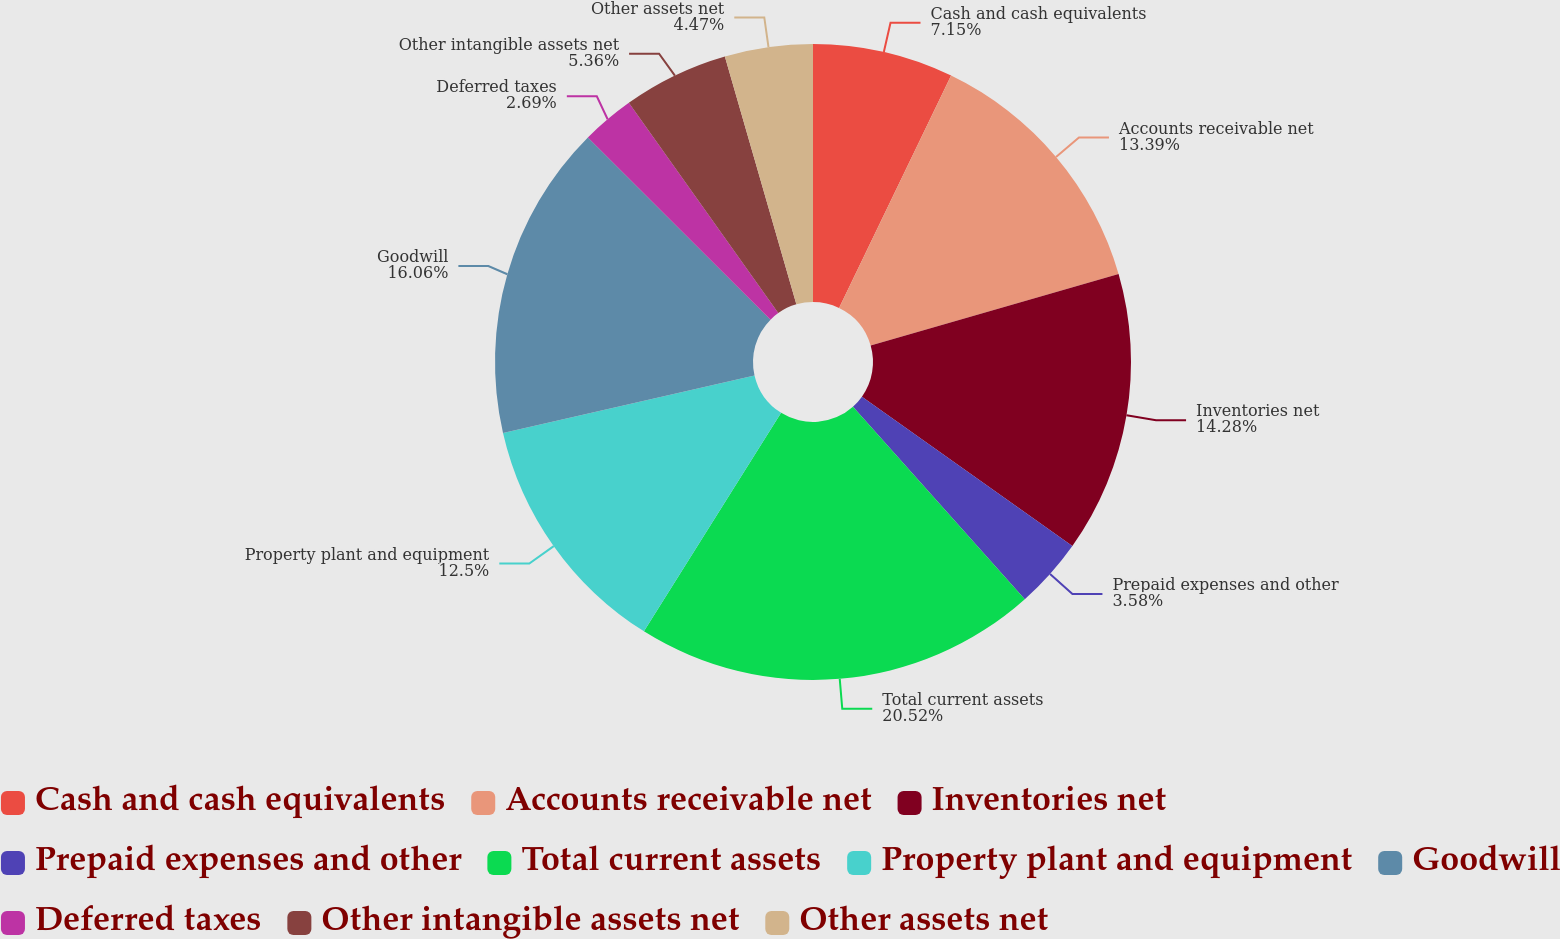Convert chart. <chart><loc_0><loc_0><loc_500><loc_500><pie_chart><fcel>Cash and cash equivalents<fcel>Accounts receivable net<fcel>Inventories net<fcel>Prepaid expenses and other<fcel>Total current assets<fcel>Property plant and equipment<fcel>Goodwill<fcel>Deferred taxes<fcel>Other intangible assets net<fcel>Other assets net<nl><fcel>7.15%<fcel>13.39%<fcel>14.28%<fcel>3.58%<fcel>20.52%<fcel>12.5%<fcel>16.06%<fcel>2.69%<fcel>5.36%<fcel>4.47%<nl></chart> 